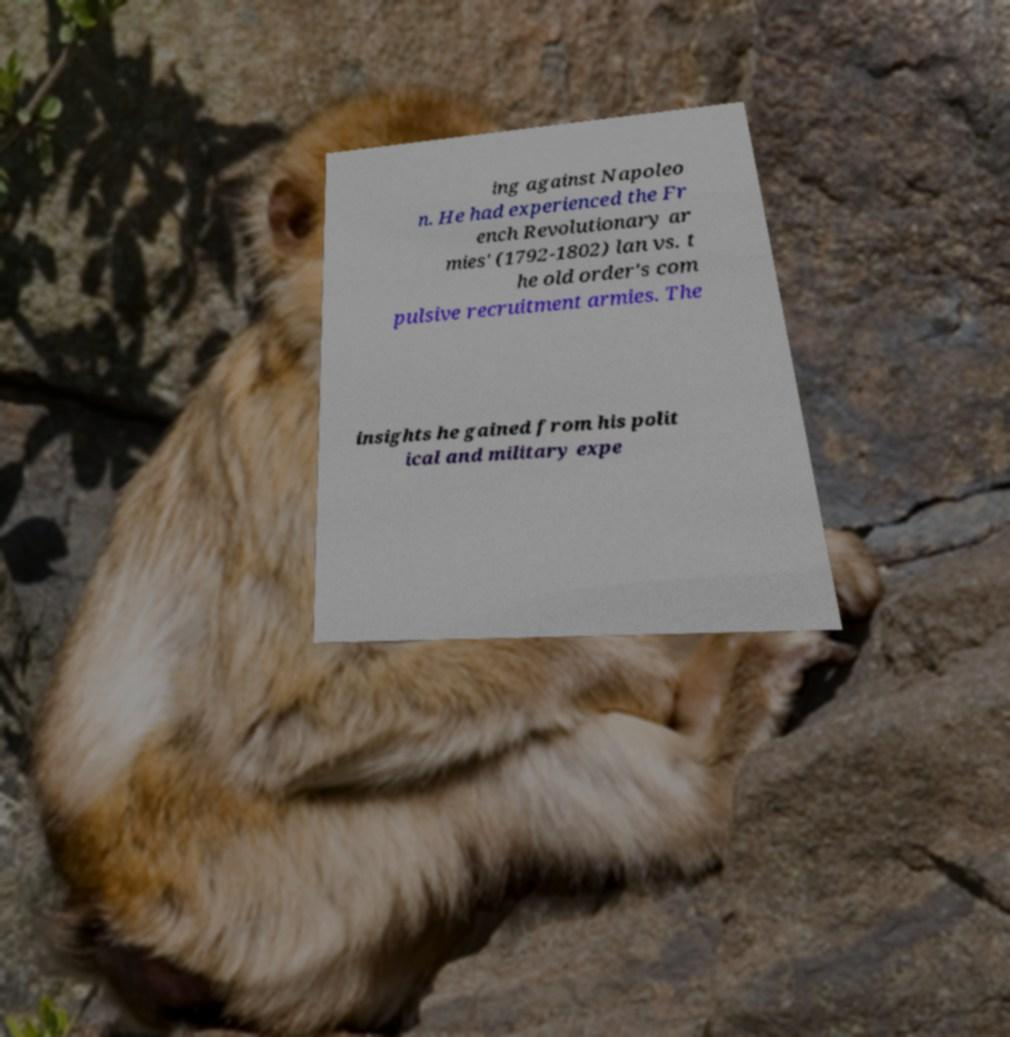Please identify and transcribe the text found in this image. ing against Napoleo n. He had experienced the Fr ench Revolutionary ar mies' (1792-1802) lan vs. t he old order's com pulsive recruitment armies. The insights he gained from his polit ical and military expe 